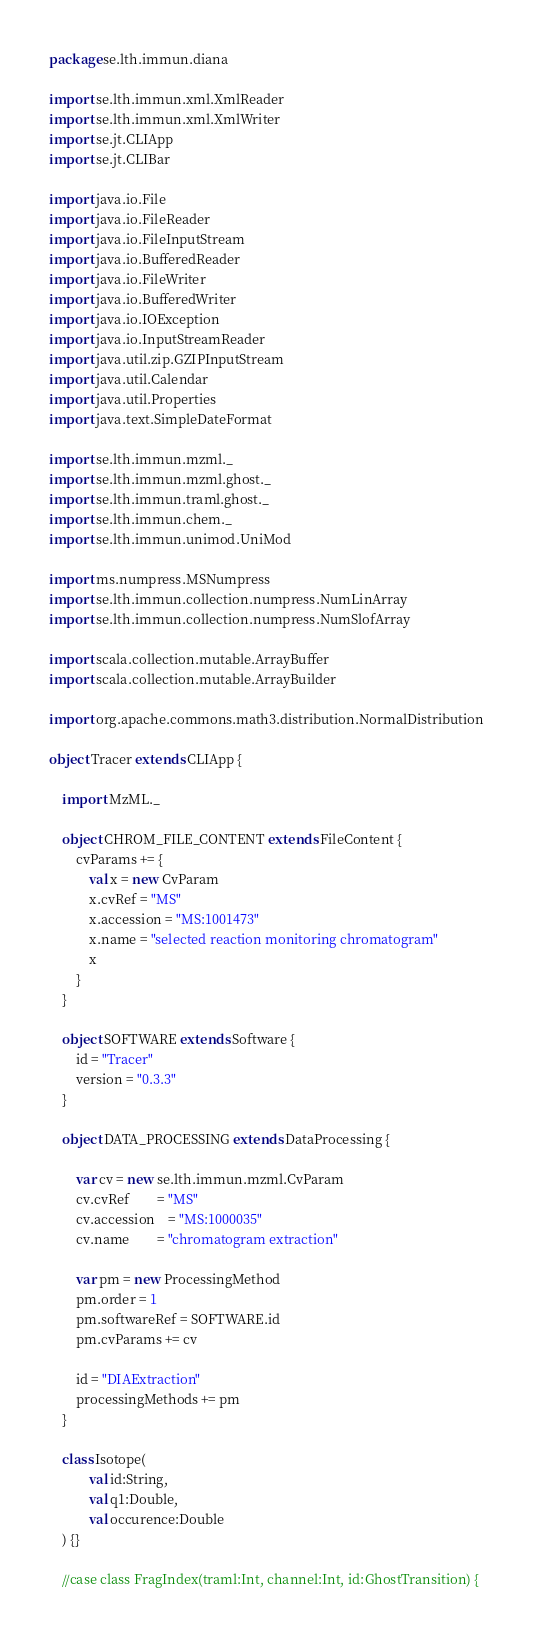Convert code to text. <code><loc_0><loc_0><loc_500><loc_500><_Scala_>package se.lth.immun.diana

import se.lth.immun.xml.XmlReader
import se.lth.immun.xml.XmlWriter
import se.jt.CLIApp
import se.jt.CLIBar

import java.io.File
import java.io.FileReader
import java.io.FileInputStream
import java.io.BufferedReader
import java.io.FileWriter
import java.io.BufferedWriter
import java.io.IOException
import java.io.InputStreamReader
import java.util.zip.GZIPInputStream
import java.util.Calendar
import java.util.Properties
import java.text.SimpleDateFormat

import se.lth.immun.mzml._
import se.lth.immun.mzml.ghost._
import se.lth.immun.traml.ghost._
import se.lth.immun.chem._
import se.lth.immun.unimod.UniMod

import ms.numpress.MSNumpress
import se.lth.immun.collection.numpress.NumLinArray
import se.lth.immun.collection.numpress.NumSlofArray

import scala.collection.mutable.ArrayBuffer
import scala.collection.mutable.ArrayBuilder

import org.apache.commons.math3.distribution.NormalDistribution

object Tracer extends CLIApp {

	import MzML._
	
	object CHROM_FILE_CONTENT extends FileContent {
		cvParams += {
			val x = new CvParam
			x.cvRef = "MS"
			x.accession = "MS:1001473"
			x.name = "selected reaction monitoring chromatogram"
			x
		}
	}
	
	object SOFTWARE extends Software {
		id = "Tracer"
		version = "0.3.3"
	}
	
	object DATA_PROCESSING extends DataProcessing {
		
		var cv = new se.lth.immun.mzml.CvParam
		cv.cvRef 		= "MS"
		cv.accession 	= "MS:1000035"
		cv.name 		= "chromatogram extraction"
		
		var pm = new ProcessingMethod
		pm.order = 1
		pm.softwareRef = SOFTWARE.id
		pm.cvParams += cv
		
		id = "DIAExtraction"
		processingMethods += pm
	}
	
	class Isotope(
			val id:String,
			val q1:Double,
			val occurence:Double
	) {}
	
	//case class FragIndex(traml:Int, channel:Int, id:GhostTransition) {</code> 